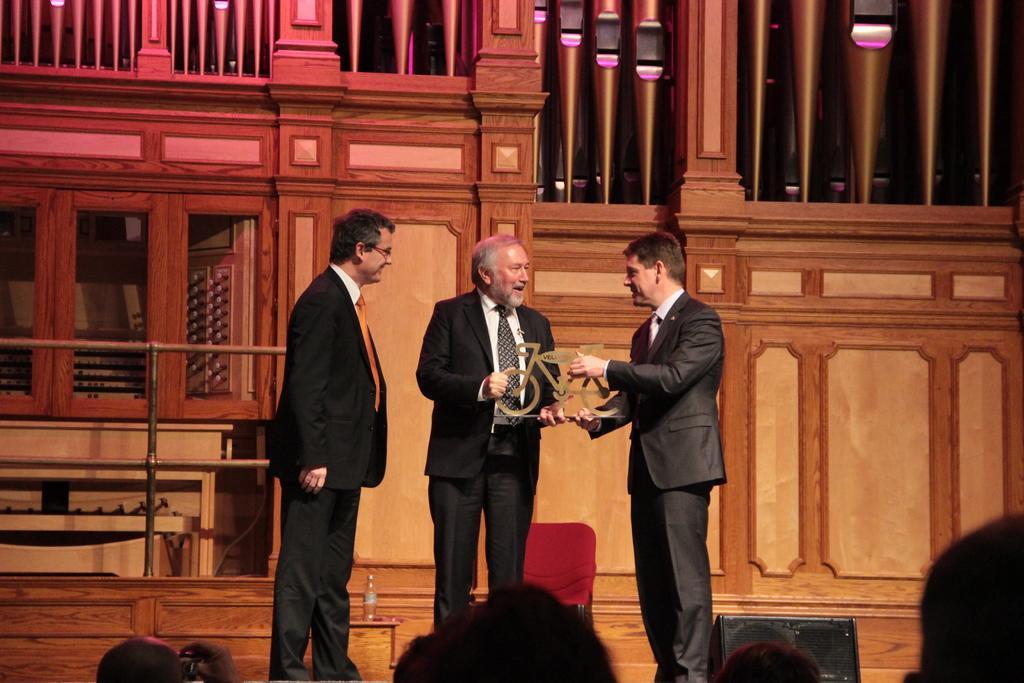In one or two sentences, can you explain what this image depicts? In the picture we can see three men are standing on the stage and one man is giving an award to another man, they are in blazers, ties and shirts and behind them we can see a structure of house wall and in front of them we can see some people. 